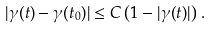<formula> <loc_0><loc_0><loc_500><loc_500>| \gamma ( t ) - \gamma ( t _ { 0 } ) | \leq C \left ( 1 - | \gamma ( t ) | \right ) \, .</formula> 